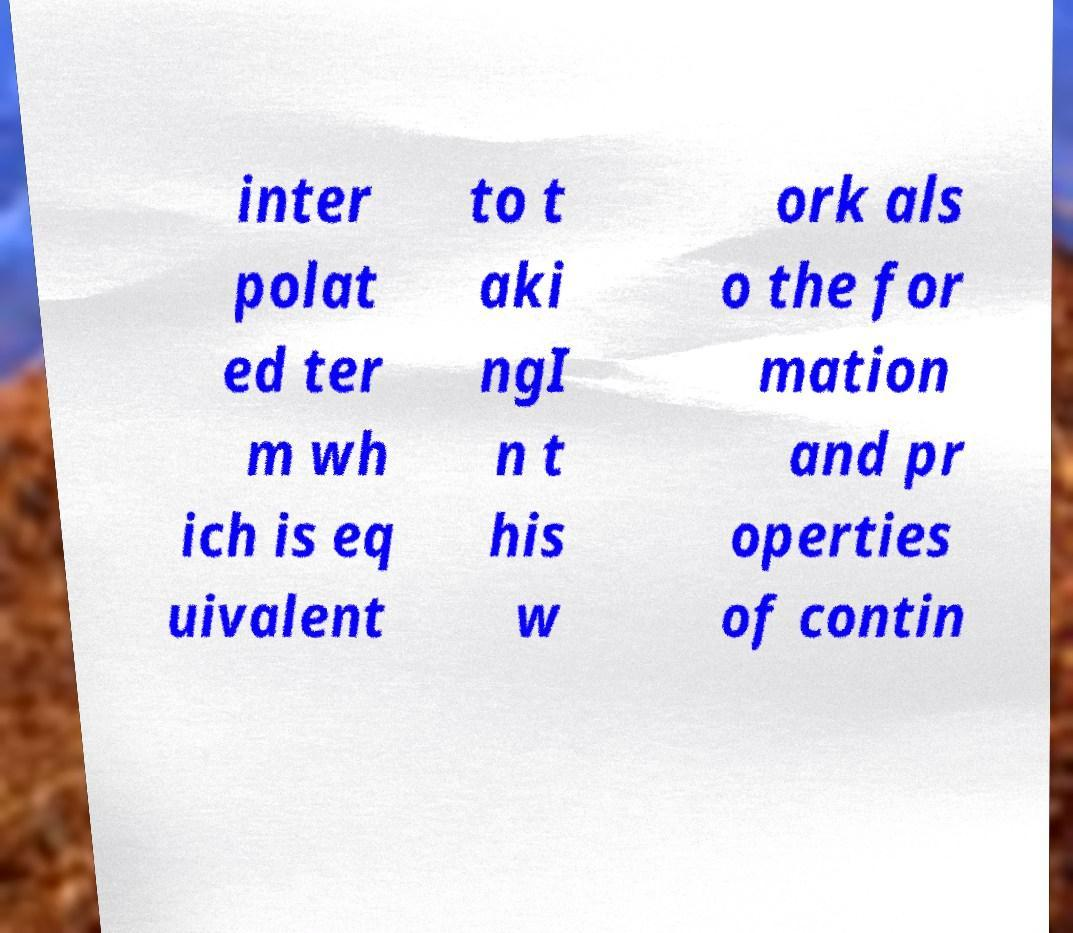Can you accurately transcribe the text from the provided image for me? inter polat ed ter m wh ich is eq uivalent to t aki ngI n t his w ork als o the for mation and pr operties of contin 